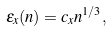<formula> <loc_0><loc_0><loc_500><loc_500>\varepsilon _ { x } ( n ) = c _ { x } n ^ { 1 / 3 } ,</formula> 